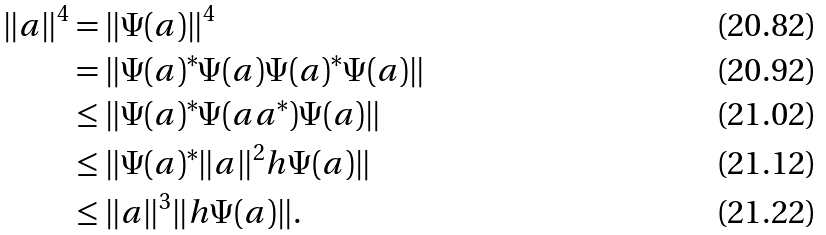<formula> <loc_0><loc_0><loc_500><loc_500>\| a \| ^ { 4 } & = \| \Psi ( a ) \| ^ { 4 } \\ & = \| \Psi ( a ) ^ { * } \Psi ( a ) \Psi ( a ) ^ { * } \Psi ( a ) \| \\ & \leq \| \Psi ( a ) ^ { * } \Psi ( a a ^ { * } ) \Psi ( a ) \| \\ & \leq \| \Psi ( a ) ^ { * } \| a \| ^ { 2 } h \Psi ( a ) \| \\ & \leq \| a \| ^ { 3 } \| h \Psi ( a ) \| .</formula> 